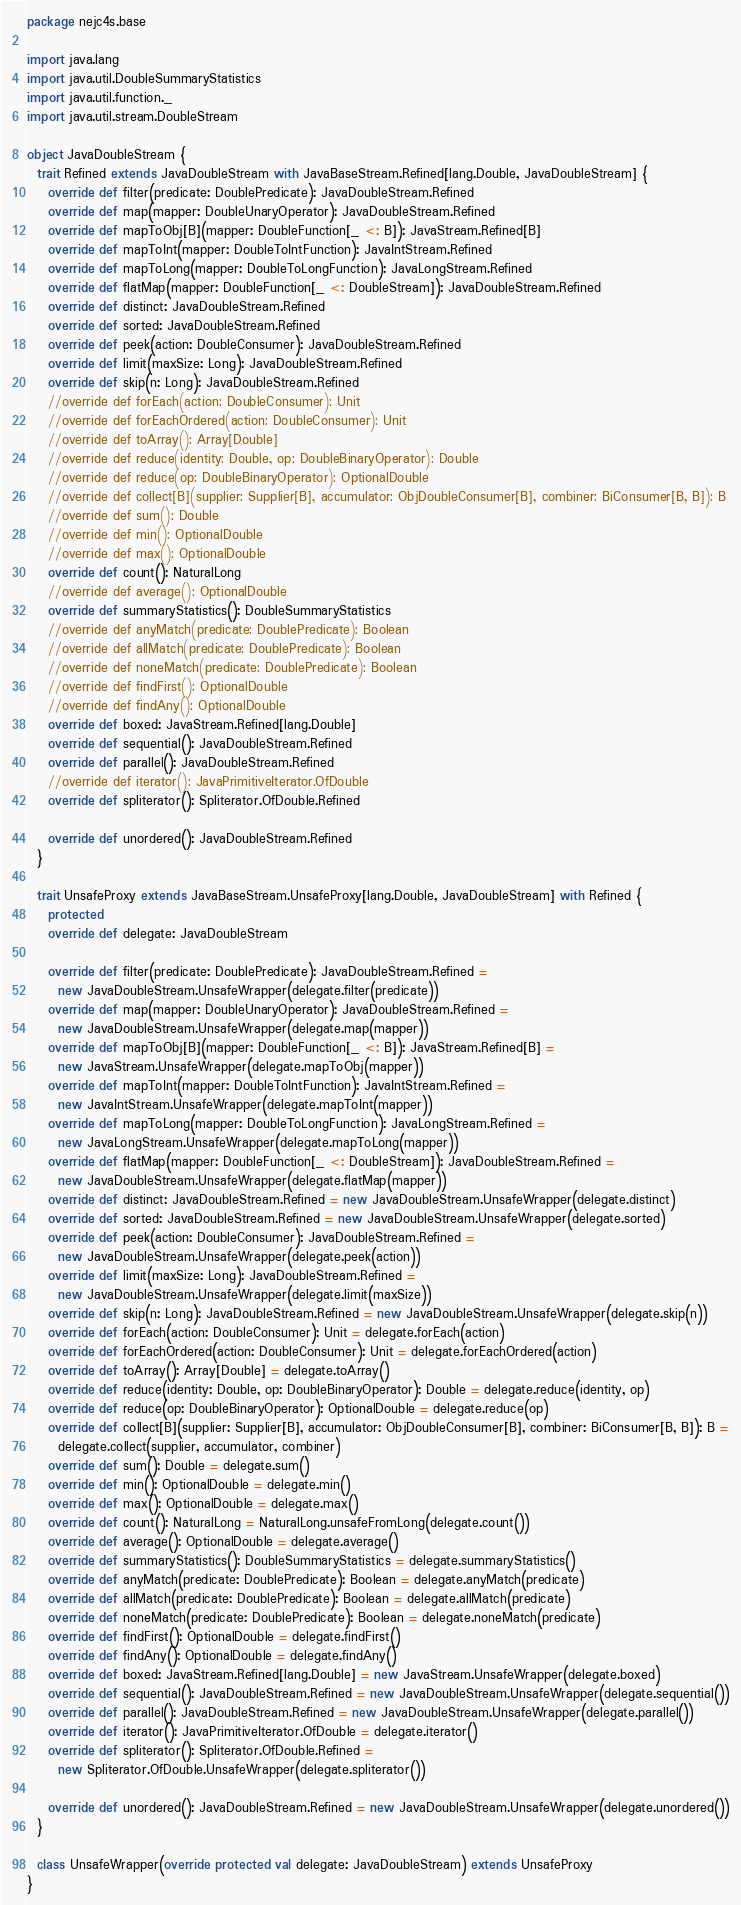Convert code to text. <code><loc_0><loc_0><loc_500><loc_500><_Scala_>package nejc4s.base

import java.lang
import java.util.DoubleSummaryStatistics
import java.util.function._
import java.util.stream.DoubleStream

object JavaDoubleStream {
  trait Refined extends JavaDoubleStream with JavaBaseStream.Refined[lang.Double, JavaDoubleStream] {
    override def filter(predicate: DoublePredicate): JavaDoubleStream.Refined
    override def map(mapper: DoubleUnaryOperator): JavaDoubleStream.Refined
    override def mapToObj[B](mapper: DoubleFunction[_ <: B]): JavaStream.Refined[B]
    override def mapToInt(mapper: DoubleToIntFunction): JavaIntStream.Refined
    override def mapToLong(mapper: DoubleToLongFunction): JavaLongStream.Refined
    override def flatMap(mapper: DoubleFunction[_ <: DoubleStream]): JavaDoubleStream.Refined
    override def distinct: JavaDoubleStream.Refined
    override def sorted: JavaDoubleStream.Refined
    override def peek(action: DoubleConsumer): JavaDoubleStream.Refined
    override def limit(maxSize: Long): JavaDoubleStream.Refined
    override def skip(n: Long): JavaDoubleStream.Refined
    //override def forEach(action: DoubleConsumer): Unit
    //override def forEachOrdered(action: DoubleConsumer): Unit
    //override def toArray(): Array[Double]
    //override def reduce(identity: Double, op: DoubleBinaryOperator): Double
    //override def reduce(op: DoubleBinaryOperator): OptionalDouble
    //override def collect[B](supplier: Supplier[B], accumulator: ObjDoubleConsumer[B], combiner: BiConsumer[B, B]): B
    //override def sum(): Double
    //override def min(): OptionalDouble
    //override def max(): OptionalDouble
    override def count(): NaturalLong
    //override def average(): OptionalDouble
    override def summaryStatistics(): DoubleSummaryStatistics
    //override def anyMatch(predicate: DoublePredicate): Boolean
    //override def allMatch(predicate: DoublePredicate): Boolean
    //override def noneMatch(predicate: DoublePredicate): Boolean
    //override def findFirst(): OptionalDouble
    //override def findAny(): OptionalDouble
    override def boxed: JavaStream.Refined[lang.Double]
    override def sequential(): JavaDoubleStream.Refined
    override def parallel(): JavaDoubleStream.Refined
    //override def iterator(): JavaPrimitiveIterator.OfDouble
    override def spliterator(): Spliterator.OfDouble.Refined

    override def unordered(): JavaDoubleStream.Refined
  }

  trait UnsafeProxy extends JavaBaseStream.UnsafeProxy[lang.Double, JavaDoubleStream] with Refined {
    protected
    override def delegate: JavaDoubleStream

    override def filter(predicate: DoublePredicate): JavaDoubleStream.Refined =
      new JavaDoubleStream.UnsafeWrapper(delegate.filter(predicate))
    override def map(mapper: DoubleUnaryOperator): JavaDoubleStream.Refined =
      new JavaDoubleStream.UnsafeWrapper(delegate.map(mapper))
    override def mapToObj[B](mapper: DoubleFunction[_ <: B]): JavaStream.Refined[B] =
      new JavaStream.UnsafeWrapper(delegate.mapToObj(mapper))
    override def mapToInt(mapper: DoubleToIntFunction): JavaIntStream.Refined =
      new JavaIntStream.UnsafeWrapper(delegate.mapToInt(mapper))
    override def mapToLong(mapper: DoubleToLongFunction): JavaLongStream.Refined =
      new JavaLongStream.UnsafeWrapper(delegate.mapToLong(mapper))
    override def flatMap(mapper: DoubleFunction[_ <: DoubleStream]): JavaDoubleStream.Refined =
      new JavaDoubleStream.UnsafeWrapper(delegate.flatMap(mapper))
    override def distinct: JavaDoubleStream.Refined = new JavaDoubleStream.UnsafeWrapper(delegate.distinct)
    override def sorted: JavaDoubleStream.Refined = new JavaDoubleStream.UnsafeWrapper(delegate.sorted)
    override def peek(action: DoubleConsumer): JavaDoubleStream.Refined =
      new JavaDoubleStream.UnsafeWrapper(delegate.peek(action))
    override def limit(maxSize: Long): JavaDoubleStream.Refined =
      new JavaDoubleStream.UnsafeWrapper(delegate.limit(maxSize))
    override def skip(n: Long): JavaDoubleStream.Refined = new JavaDoubleStream.UnsafeWrapper(delegate.skip(n))
    override def forEach(action: DoubleConsumer): Unit = delegate.forEach(action)
    override def forEachOrdered(action: DoubleConsumer): Unit = delegate.forEachOrdered(action)
    override def toArray(): Array[Double] = delegate.toArray()
    override def reduce(identity: Double, op: DoubleBinaryOperator): Double = delegate.reduce(identity, op)
    override def reduce(op: DoubleBinaryOperator): OptionalDouble = delegate.reduce(op)
    override def collect[B](supplier: Supplier[B], accumulator: ObjDoubleConsumer[B], combiner: BiConsumer[B, B]): B =
      delegate.collect(supplier, accumulator, combiner)
    override def sum(): Double = delegate.sum()
    override def min(): OptionalDouble = delegate.min()
    override def max(): OptionalDouble = delegate.max()
    override def count(): NaturalLong = NaturalLong.unsafeFromLong(delegate.count())
    override def average(): OptionalDouble = delegate.average()
    override def summaryStatistics(): DoubleSummaryStatistics = delegate.summaryStatistics()
    override def anyMatch(predicate: DoublePredicate): Boolean = delegate.anyMatch(predicate)
    override def allMatch(predicate: DoublePredicate): Boolean = delegate.allMatch(predicate)
    override def noneMatch(predicate: DoublePredicate): Boolean = delegate.noneMatch(predicate)
    override def findFirst(): OptionalDouble = delegate.findFirst()
    override def findAny(): OptionalDouble = delegate.findAny()
    override def boxed: JavaStream.Refined[lang.Double] = new JavaStream.UnsafeWrapper(delegate.boxed)
    override def sequential(): JavaDoubleStream.Refined = new JavaDoubleStream.UnsafeWrapper(delegate.sequential())
    override def parallel(): JavaDoubleStream.Refined = new JavaDoubleStream.UnsafeWrapper(delegate.parallel())
    override def iterator(): JavaPrimitiveIterator.OfDouble = delegate.iterator()
    override def spliterator(): Spliterator.OfDouble.Refined =
      new Spliterator.OfDouble.UnsafeWrapper(delegate.spliterator())

    override def unordered(): JavaDoubleStream.Refined = new JavaDoubleStream.UnsafeWrapper(delegate.unordered())
  }

  class UnsafeWrapper(override protected val delegate: JavaDoubleStream) extends UnsafeProxy
}
</code> 